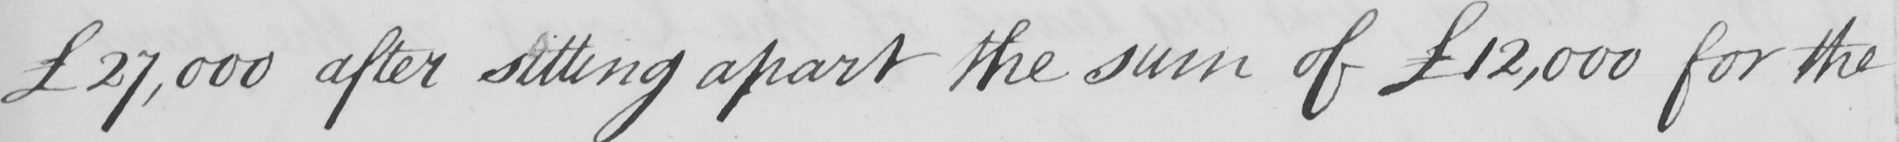What text is written in this handwritten line? £27,000 after sitting apart the sum of  £12,000 for the 